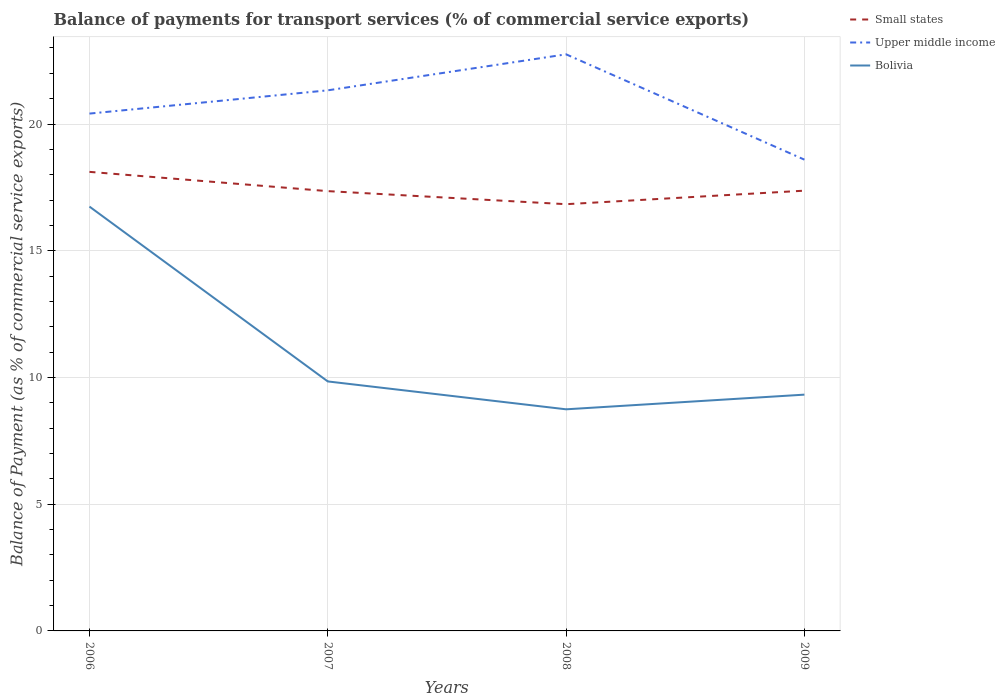How many different coloured lines are there?
Provide a short and direct response. 3. Does the line corresponding to Small states intersect with the line corresponding to Upper middle income?
Offer a terse response. No. Across all years, what is the maximum balance of payments for transport services in Upper middle income?
Make the answer very short. 18.59. What is the total balance of payments for transport services in Upper middle income in the graph?
Provide a short and direct response. 1.82. What is the difference between the highest and the second highest balance of payments for transport services in Small states?
Provide a short and direct response. 1.28. What is the difference between the highest and the lowest balance of payments for transport services in Bolivia?
Keep it short and to the point. 1. Is the balance of payments for transport services in Upper middle income strictly greater than the balance of payments for transport services in Bolivia over the years?
Make the answer very short. No. How many lines are there?
Your answer should be very brief. 3. Are the values on the major ticks of Y-axis written in scientific E-notation?
Give a very brief answer. No. Does the graph contain any zero values?
Ensure brevity in your answer.  No. Does the graph contain grids?
Your answer should be very brief. Yes. How many legend labels are there?
Offer a terse response. 3. What is the title of the graph?
Your response must be concise. Balance of payments for transport services (% of commercial service exports). What is the label or title of the Y-axis?
Keep it short and to the point. Balance of Payment (as % of commercial service exports). What is the Balance of Payment (as % of commercial service exports) in Small states in 2006?
Make the answer very short. 18.11. What is the Balance of Payment (as % of commercial service exports) in Upper middle income in 2006?
Your answer should be compact. 20.41. What is the Balance of Payment (as % of commercial service exports) of Bolivia in 2006?
Ensure brevity in your answer.  16.74. What is the Balance of Payment (as % of commercial service exports) of Small states in 2007?
Your answer should be compact. 17.35. What is the Balance of Payment (as % of commercial service exports) in Upper middle income in 2007?
Ensure brevity in your answer.  21.33. What is the Balance of Payment (as % of commercial service exports) of Bolivia in 2007?
Offer a very short reply. 9.84. What is the Balance of Payment (as % of commercial service exports) in Small states in 2008?
Your response must be concise. 16.84. What is the Balance of Payment (as % of commercial service exports) of Upper middle income in 2008?
Offer a very short reply. 22.75. What is the Balance of Payment (as % of commercial service exports) in Bolivia in 2008?
Provide a succinct answer. 8.74. What is the Balance of Payment (as % of commercial service exports) of Small states in 2009?
Keep it short and to the point. 17.37. What is the Balance of Payment (as % of commercial service exports) in Upper middle income in 2009?
Provide a short and direct response. 18.59. What is the Balance of Payment (as % of commercial service exports) of Bolivia in 2009?
Offer a very short reply. 9.32. Across all years, what is the maximum Balance of Payment (as % of commercial service exports) of Small states?
Keep it short and to the point. 18.11. Across all years, what is the maximum Balance of Payment (as % of commercial service exports) in Upper middle income?
Make the answer very short. 22.75. Across all years, what is the maximum Balance of Payment (as % of commercial service exports) of Bolivia?
Your answer should be compact. 16.74. Across all years, what is the minimum Balance of Payment (as % of commercial service exports) in Small states?
Make the answer very short. 16.84. Across all years, what is the minimum Balance of Payment (as % of commercial service exports) of Upper middle income?
Provide a succinct answer. 18.59. Across all years, what is the minimum Balance of Payment (as % of commercial service exports) of Bolivia?
Provide a succinct answer. 8.74. What is the total Balance of Payment (as % of commercial service exports) of Small states in the graph?
Your answer should be very brief. 69.67. What is the total Balance of Payment (as % of commercial service exports) in Upper middle income in the graph?
Keep it short and to the point. 83.09. What is the total Balance of Payment (as % of commercial service exports) of Bolivia in the graph?
Make the answer very short. 44.65. What is the difference between the Balance of Payment (as % of commercial service exports) in Small states in 2006 and that in 2007?
Provide a short and direct response. 0.76. What is the difference between the Balance of Payment (as % of commercial service exports) of Upper middle income in 2006 and that in 2007?
Make the answer very short. -0.92. What is the difference between the Balance of Payment (as % of commercial service exports) in Bolivia in 2006 and that in 2007?
Your response must be concise. 6.9. What is the difference between the Balance of Payment (as % of commercial service exports) in Small states in 2006 and that in 2008?
Make the answer very short. 1.28. What is the difference between the Balance of Payment (as % of commercial service exports) of Upper middle income in 2006 and that in 2008?
Keep it short and to the point. -2.34. What is the difference between the Balance of Payment (as % of commercial service exports) in Bolivia in 2006 and that in 2008?
Give a very brief answer. 8. What is the difference between the Balance of Payment (as % of commercial service exports) of Small states in 2006 and that in 2009?
Give a very brief answer. 0.74. What is the difference between the Balance of Payment (as % of commercial service exports) of Upper middle income in 2006 and that in 2009?
Keep it short and to the point. 1.82. What is the difference between the Balance of Payment (as % of commercial service exports) in Bolivia in 2006 and that in 2009?
Ensure brevity in your answer.  7.42. What is the difference between the Balance of Payment (as % of commercial service exports) of Small states in 2007 and that in 2008?
Your answer should be compact. 0.52. What is the difference between the Balance of Payment (as % of commercial service exports) in Upper middle income in 2007 and that in 2008?
Give a very brief answer. -1.42. What is the difference between the Balance of Payment (as % of commercial service exports) of Bolivia in 2007 and that in 2008?
Provide a short and direct response. 1.1. What is the difference between the Balance of Payment (as % of commercial service exports) of Small states in 2007 and that in 2009?
Your response must be concise. -0.02. What is the difference between the Balance of Payment (as % of commercial service exports) of Upper middle income in 2007 and that in 2009?
Provide a succinct answer. 2.73. What is the difference between the Balance of Payment (as % of commercial service exports) in Bolivia in 2007 and that in 2009?
Your answer should be compact. 0.52. What is the difference between the Balance of Payment (as % of commercial service exports) of Small states in 2008 and that in 2009?
Your response must be concise. -0.53. What is the difference between the Balance of Payment (as % of commercial service exports) of Upper middle income in 2008 and that in 2009?
Provide a short and direct response. 4.16. What is the difference between the Balance of Payment (as % of commercial service exports) of Bolivia in 2008 and that in 2009?
Your answer should be very brief. -0.58. What is the difference between the Balance of Payment (as % of commercial service exports) of Small states in 2006 and the Balance of Payment (as % of commercial service exports) of Upper middle income in 2007?
Ensure brevity in your answer.  -3.22. What is the difference between the Balance of Payment (as % of commercial service exports) in Small states in 2006 and the Balance of Payment (as % of commercial service exports) in Bolivia in 2007?
Keep it short and to the point. 8.27. What is the difference between the Balance of Payment (as % of commercial service exports) of Upper middle income in 2006 and the Balance of Payment (as % of commercial service exports) of Bolivia in 2007?
Provide a short and direct response. 10.57. What is the difference between the Balance of Payment (as % of commercial service exports) in Small states in 2006 and the Balance of Payment (as % of commercial service exports) in Upper middle income in 2008?
Provide a succinct answer. -4.64. What is the difference between the Balance of Payment (as % of commercial service exports) of Small states in 2006 and the Balance of Payment (as % of commercial service exports) of Bolivia in 2008?
Make the answer very short. 9.37. What is the difference between the Balance of Payment (as % of commercial service exports) in Upper middle income in 2006 and the Balance of Payment (as % of commercial service exports) in Bolivia in 2008?
Your response must be concise. 11.67. What is the difference between the Balance of Payment (as % of commercial service exports) in Small states in 2006 and the Balance of Payment (as % of commercial service exports) in Upper middle income in 2009?
Your answer should be very brief. -0.48. What is the difference between the Balance of Payment (as % of commercial service exports) of Small states in 2006 and the Balance of Payment (as % of commercial service exports) of Bolivia in 2009?
Ensure brevity in your answer.  8.79. What is the difference between the Balance of Payment (as % of commercial service exports) of Upper middle income in 2006 and the Balance of Payment (as % of commercial service exports) of Bolivia in 2009?
Make the answer very short. 11.09. What is the difference between the Balance of Payment (as % of commercial service exports) in Small states in 2007 and the Balance of Payment (as % of commercial service exports) in Upper middle income in 2008?
Offer a very short reply. -5.4. What is the difference between the Balance of Payment (as % of commercial service exports) of Small states in 2007 and the Balance of Payment (as % of commercial service exports) of Bolivia in 2008?
Provide a short and direct response. 8.61. What is the difference between the Balance of Payment (as % of commercial service exports) in Upper middle income in 2007 and the Balance of Payment (as % of commercial service exports) in Bolivia in 2008?
Your response must be concise. 12.59. What is the difference between the Balance of Payment (as % of commercial service exports) in Small states in 2007 and the Balance of Payment (as % of commercial service exports) in Upper middle income in 2009?
Give a very brief answer. -1.24. What is the difference between the Balance of Payment (as % of commercial service exports) in Small states in 2007 and the Balance of Payment (as % of commercial service exports) in Bolivia in 2009?
Your answer should be very brief. 8.03. What is the difference between the Balance of Payment (as % of commercial service exports) in Upper middle income in 2007 and the Balance of Payment (as % of commercial service exports) in Bolivia in 2009?
Make the answer very short. 12.01. What is the difference between the Balance of Payment (as % of commercial service exports) of Small states in 2008 and the Balance of Payment (as % of commercial service exports) of Upper middle income in 2009?
Give a very brief answer. -1.76. What is the difference between the Balance of Payment (as % of commercial service exports) in Small states in 2008 and the Balance of Payment (as % of commercial service exports) in Bolivia in 2009?
Make the answer very short. 7.51. What is the difference between the Balance of Payment (as % of commercial service exports) in Upper middle income in 2008 and the Balance of Payment (as % of commercial service exports) in Bolivia in 2009?
Your response must be concise. 13.43. What is the average Balance of Payment (as % of commercial service exports) in Small states per year?
Make the answer very short. 17.42. What is the average Balance of Payment (as % of commercial service exports) of Upper middle income per year?
Ensure brevity in your answer.  20.77. What is the average Balance of Payment (as % of commercial service exports) in Bolivia per year?
Offer a very short reply. 11.16. In the year 2006, what is the difference between the Balance of Payment (as % of commercial service exports) of Small states and Balance of Payment (as % of commercial service exports) of Upper middle income?
Ensure brevity in your answer.  -2.3. In the year 2006, what is the difference between the Balance of Payment (as % of commercial service exports) in Small states and Balance of Payment (as % of commercial service exports) in Bolivia?
Provide a short and direct response. 1.37. In the year 2006, what is the difference between the Balance of Payment (as % of commercial service exports) in Upper middle income and Balance of Payment (as % of commercial service exports) in Bolivia?
Your response must be concise. 3.67. In the year 2007, what is the difference between the Balance of Payment (as % of commercial service exports) in Small states and Balance of Payment (as % of commercial service exports) in Upper middle income?
Offer a terse response. -3.98. In the year 2007, what is the difference between the Balance of Payment (as % of commercial service exports) in Small states and Balance of Payment (as % of commercial service exports) in Bolivia?
Provide a short and direct response. 7.51. In the year 2007, what is the difference between the Balance of Payment (as % of commercial service exports) in Upper middle income and Balance of Payment (as % of commercial service exports) in Bolivia?
Make the answer very short. 11.49. In the year 2008, what is the difference between the Balance of Payment (as % of commercial service exports) in Small states and Balance of Payment (as % of commercial service exports) in Upper middle income?
Keep it short and to the point. -5.91. In the year 2008, what is the difference between the Balance of Payment (as % of commercial service exports) in Small states and Balance of Payment (as % of commercial service exports) in Bolivia?
Your answer should be compact. 8.09. In the year 2008, what is the difference between the Balance of Payment (as % of commercial service exports) in Upper middle income and Balance of Payment (as % of commercial service exports) in Bolivia?
Ensure brevity in your answer.  14.01. In the year 2009, what is the difference between the Balance of Payment (as % of commercial service exports) in Small states and Balance of Payment (as % of commercial service exports) in Upper middle income?
Your answer should be very brief. -1.22. In the year 2009, what is the difference between the Balance of Payment (as % of commercial service exports) of Small states and Balance of Payment (as % of commercial service exports) of Bolivia?
Keep it short and to the point. 8.05. In the year 2009, what is the difference between the Balance of Payment (as % of commercial service exports) in Upper middle income and Balance of Payment (as % of commercial service exports) in Bolivia?
Offer a terse response. 9.27. What is the ratio of the Balance of Payment (as % of commercial service exports) of Small states in 2006 to that in 2007?
Your answer should be very brief. 1.04. What is the ratio of the Balance of Payment (as % of commercial service exports) of Upper middle income in 2006 to that in 2007?
Provide a succinct answer. 0.96. What is the ratio of the Balance of Payment (as % of commercial service exports) in Bolivia in 2006 to that in 2007?
Offer a very short reply. 1.7. What is the ratio of the Balance of Payment (as % of commercial service exports) in Small states in 2006 to that in 2008?
Your answer should be compact. 1.08. What is the ratio of the Balance of Payment (as % of commercial service exports) of Upper middle income in 2006 to that in 2008?
Make the answer very short. 0.9. What is the ratio of the Balance of Payment (as % of commercial service exports) of Bolivia in 2006 to that in 2008?
Offer a terse response. 1.91. What is the ratio of the Balance of Payment (as % of commercial service exports) of Small states in 2006 to that in 2009?
Offer a terse response. 1.04. What is the ratio of the Balance of Payment (as % of commercial service exports) of Upper middle income in 2006 to that in 2009?
Make the answer very short. 1.1. What is the ratio of the Balance of Payment (as % of commercial service exports) in Bolivia in 2006 to that in 2009?
Provide a succinct answer. 1.8. What is the ratio of the Balance of Payment (as % of commercial service exports) in Small states in 2007 to that in 2008?
Provide a succinct answer. 1.03. What is the ratio of the Balance of Payment (as % of commercial service exports) in Upper middle income in 2007 to that in 2008?
Provide a short and direct response. 0.94. What is the ratio of the Balance of Payment (as % of commercial service exports) in Bolivia in 2007 to that in 2008?
Your answer should be very brief. 1.13. What is the ratio of the Balance of Payment (as % of commercial service exports) of Upper middle income in 2007 to that in 2009?
Provide a short and direct response. 1.15. What is the ratio of the Balance of Payment (as % of commercial service exports) of Bolivia in 2007 to that in 2009?
Offer a very short reply. 1.06. What is the ratio of the Balance of Payment (as % of commercial service exports) of Small states in 2008 to that in 2009?
Give a very brief answer. 0.97. What is the ratio of the Balance of Payment (as % of commercial service exports) in Upper middle income in 2008 to that in 2009?
Ensure brevity in your answer.  1.22. What is the ratio of the Balance of Payment (as % of commercial service exports) in Bolivia in 2008 to that in 2009?
Provide a short and direct response. 0.94. What is the difference between the highest and the second highest Balance of Payment (as % of commercial service exports) of Small states?
Offer a very short reply. 0.74. What is the difference between the highest and the second highest Balance of Payment (as % of commercial service exports) in Upper middle income?
Provide a succinct answer. 1.42. What is the difference between the highest and the second highest Balance of Payment (as % of commercial service exports) in Bolivia?
Your response must be concise. 6.9. What is the difference between the highest and the lowest Balance of Payment (as % of commercial service exports) of Small states?
Your answer should be compact. 1.28. What is the difference between the highest and the lowest Balance of Payment (as % of commercial service exports) of Upper middle income?
Your answer should be very brief. 4.16. What is the difference between the highest and the lowest Balance of Payment (as % of commercial service exports) in Bolivia?
Ensure brevity in your answer.  8. 